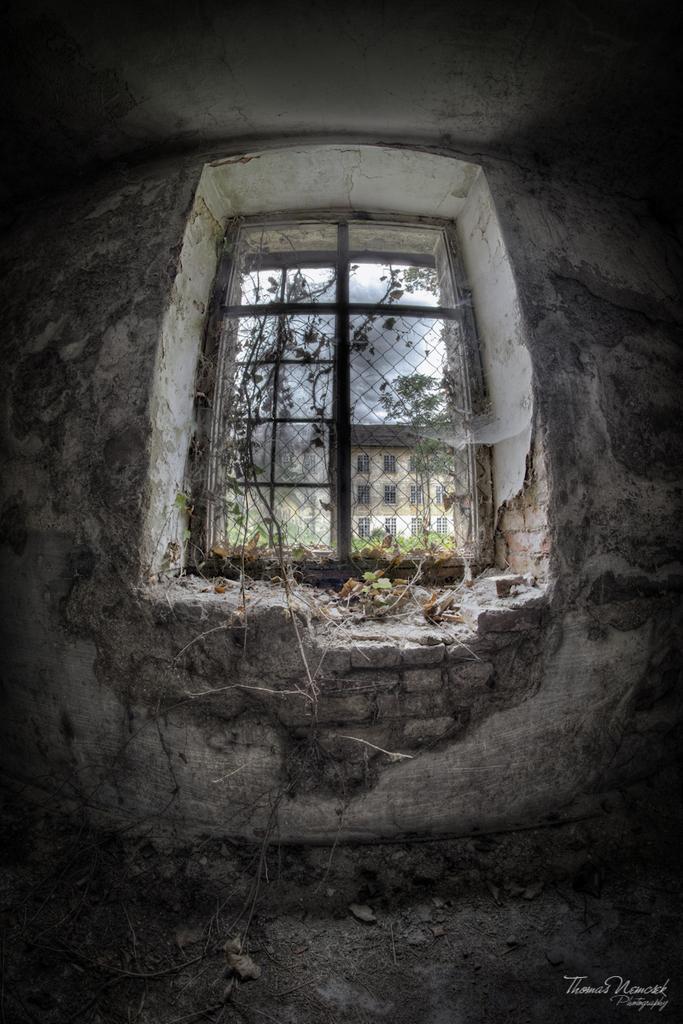Can you describe this image briefly? In the image I can see a wall, a window, a building, the sky and trees. On the bottom right corner of the I can see a watermark. 